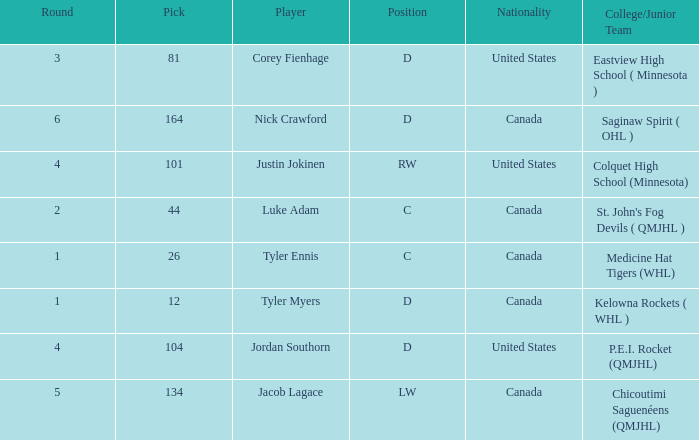What is the nationality of player corey fienhage, who has a pick less than 104? United States. 